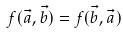<formula> <loc_0><loc_0><loc_500><loc_500>f ( \vec { a } , \vec { b } ) = f ( \vec { b } , \vec { a } )</formula> 